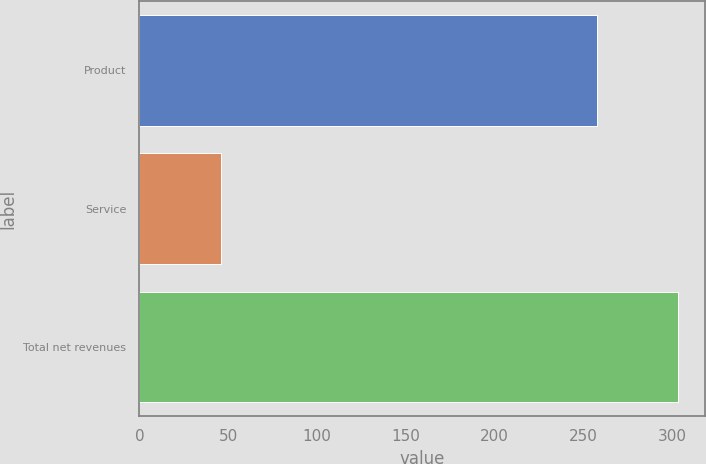<chart> <loc_0><loc_0><loc_500><loc_500><bar_chart><fcel>Product<fcel>Service<fcel>Total net revenues<nl><fcel>257.8<fcel>45.9<fcel>303.7<nl></chart> 